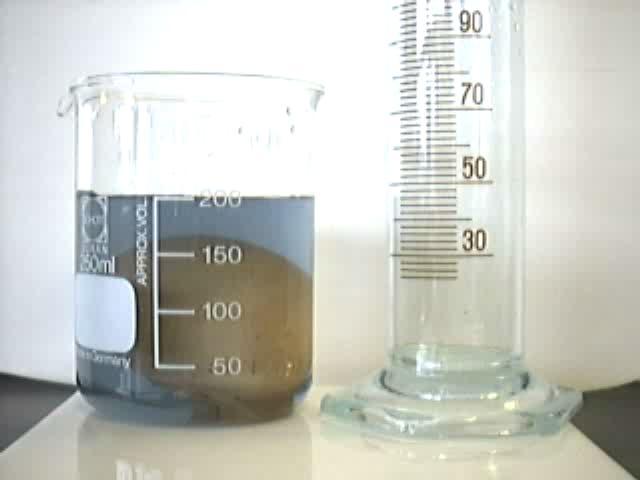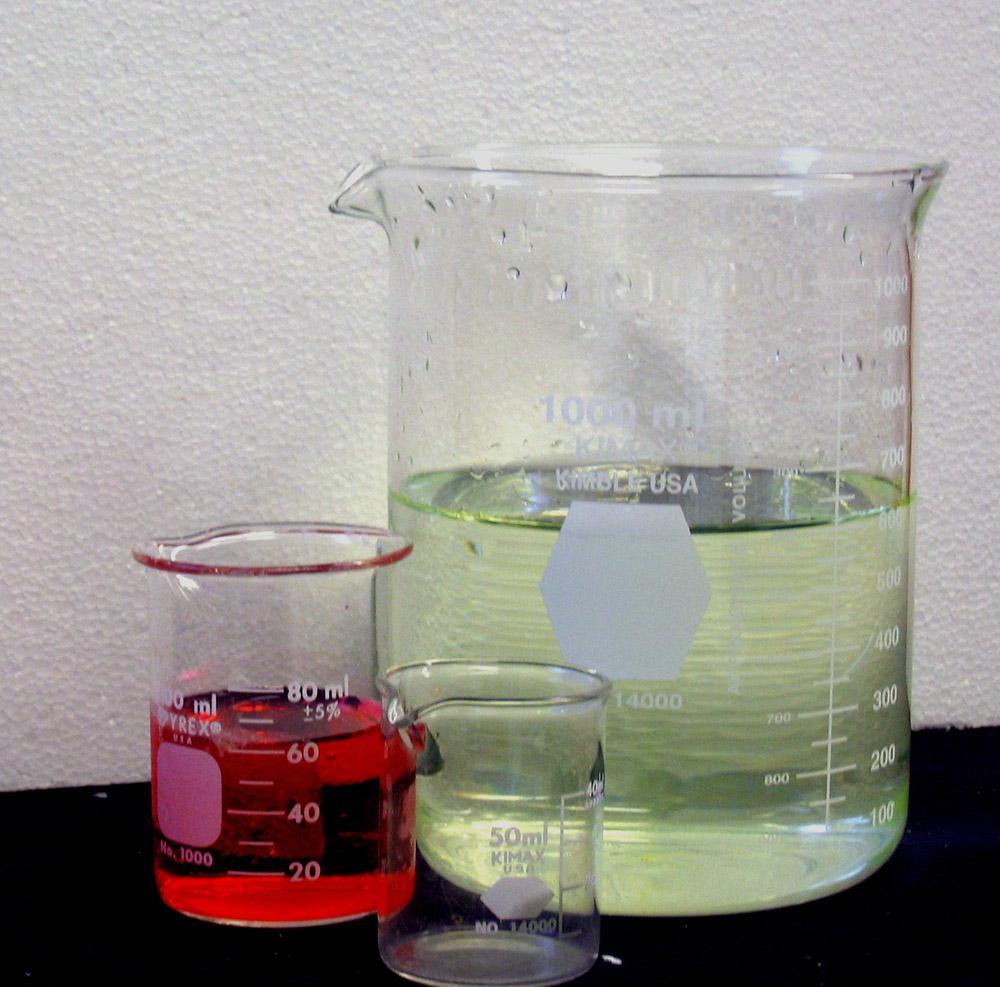The first image is the image on the left, the second image is the image on the right. Evaluate the accuracy of this statement regarding the images: "The right image includes a beaker containing bright red liquid.". Is it true? Answer yes or no. Yes. 